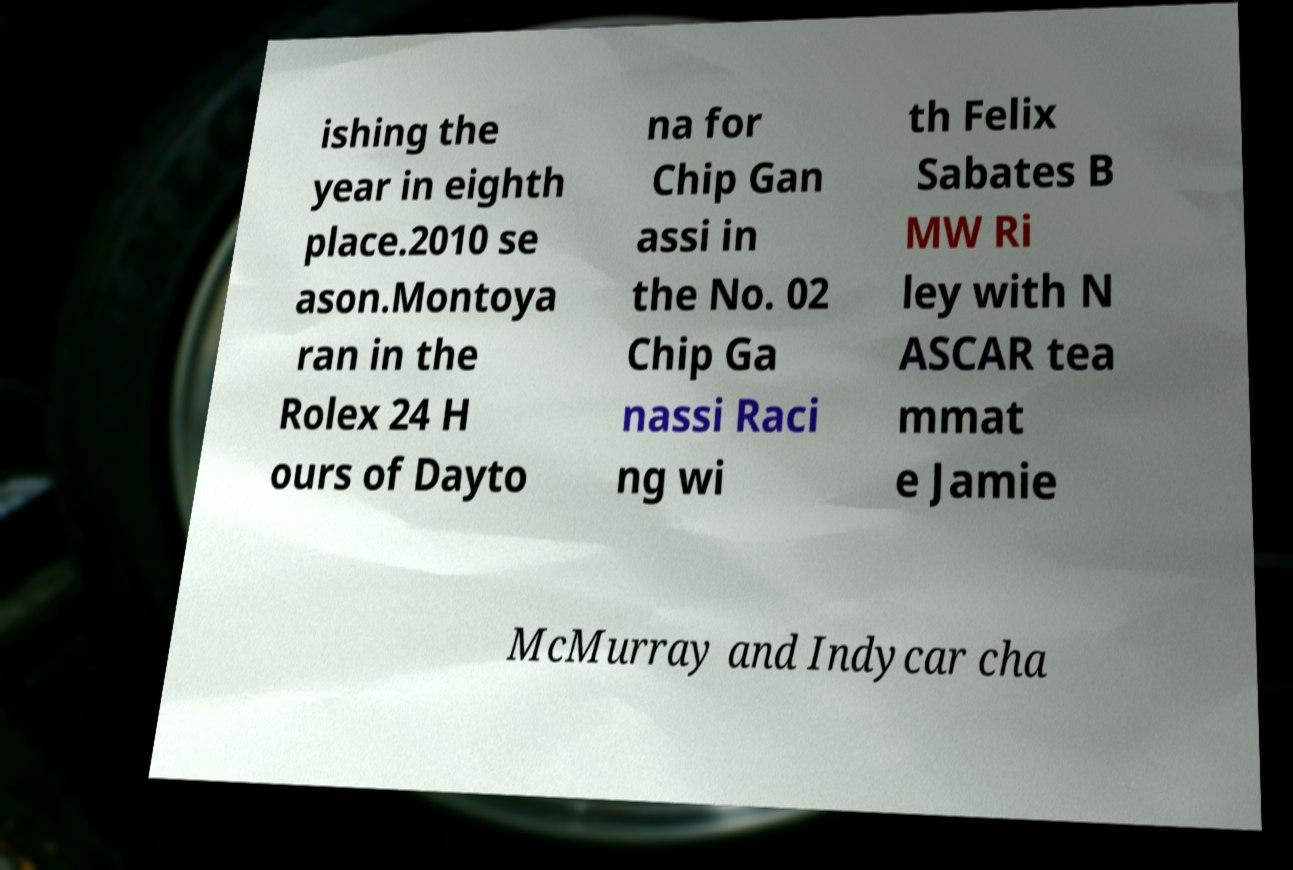Please read and relay the text visible in this image. What does it say? ishing the year in eighth place.2010 se ason.Montoya ran in the Rolex 24 H ours of Dayto na for Chip Gan assi in the No. 02 Chip Ga nassi Raci ng wi th Felix Sabates B MW Ri ley with N ASCAR tea mmat e Jamie McMurray and Indycar cha 